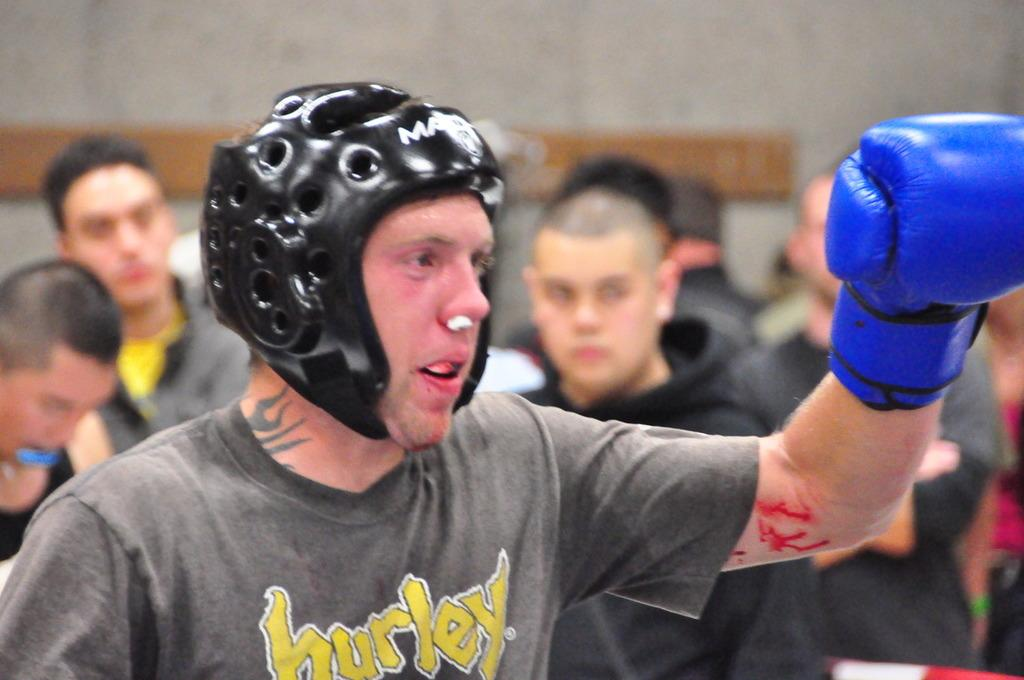What is the person in the image wearing on their head? The person in the image is wearing a black helmet. What else is the person wearing? The person is also wearing a glove. Are there any other people in the image? Yes, there are other people behind the person with the helmet. What can be seen in the background of the image? There is a wall visible in the image. Can you see a goat in the image? No, there is no goat present in the image. Is the person's grandmother visible in the image? There is no mention of a grandmother in the image, and no such person is visible. 